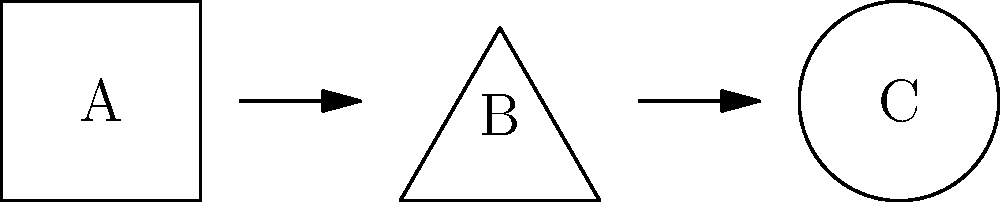In the diagram above, three different cannabis grow configurations are shown: square (A), triangle (B), and circle (C). If each configuration has the same total growing area, which arrangement would allow for the most efficient use of space for cannabis plants, considering factors such as light distribution and air circulation? To determine the most efficient grow configuration for cannabis plants, we need to consider several factors:

1. Light distribution: 
   - Square (A): Uniform light distribution, but potential shadowing in corners.
   - Triangle (B): Uneven light distribution, with more intense light at the apex.
   - Circle (C): Most uniform light distribution, minimizing shadows.

2. Air circulation:
   - Square (A): Potential for stagnant air in corners.
   - Triangle (B): Better air flow due to lack of corners, but uneven distribution.
   - Circle (C): Optimal air circulation with no corners and even distribution.

3. Space utilization:
   - Square (A): Efficient use of rectangular grow spaces, but wasted space in corners.
   - Triangle (B): Less efficient use of space, with awkward gaps between plants.
   - Circle (C): Most efficient use of space, allowing for optimal plant arrangement.

4. Plant density:
   - Square (A): Allows for a structured grid layout, but may limit plant size.
   - Triangle (B): Uneven plant spacing, potentially limiting overall yield.
   - Circle (C): Allows for more flexible plant spacing and maximizes growing area.

5. Canopy management:
   - Square (A): Easy to implement SCROG (Screen of Green) techniques.
   - Triangle (B): Challenging to implement uniform canopy management.
   - Circle (C): Allows for radial canopy management, maximizing light exposure.

Considering these factors, the circular configuration (C) provides the most efficient use of space for cannabis plants. It offers the best light distribution, air circulation, space utilization, and flexibility in plant arrangement.
Answer: Circular configuration (C) 